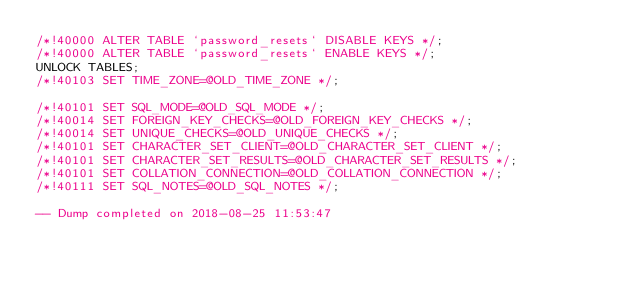<code> <loc_0><loc_0><loc_500><loc_500><_SQL_>/*!40000 ALTER TABLE `password_resets` DISABLE KEYS */;
/*!40000 ALTER TABLE `password_resets` ENABLE KEYS */;
UNLOCK TABLES;
/*!40103 SET TIME_ZONE=@OLD_TIME_ZONE */;

/*!40101 SET SQL_MODE=@OLD_SQL_MODE */;
/*!40014 SET FOREIGN_KEY_CHECKS=@OLD_FOREIGN_KEY_CHECKS */;
/*!40014 SET UNIQUE_CHECKS=@OLD_UNIQUE_CHECKS */;
/*!40101 SET CHARACTER_SET_CLIENT=@OLD_CHARACTER_SET_CLIENT */;
/*!40101 SET CHARACTER_SET_RESULTS=@OLD_CHARACTER_SET_RESULTS */;
/*!40101 SET COLLATION_CONNECTION=@OLD_COLLATION_CONNECTION */;
/*!40111 SET SQL_NOTES=@OLD_SQL_NOTES */;

-- Dump completed on 2018-08-25 11:53:47
</code> 